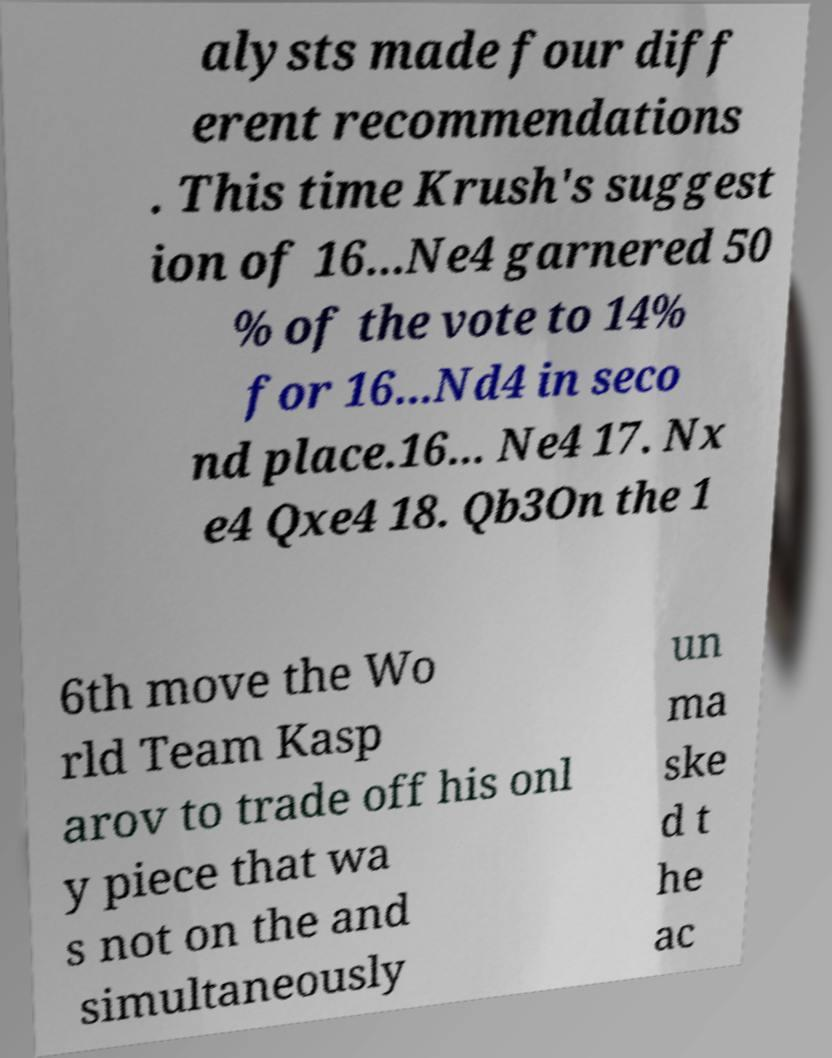Can you read and provide the text displayed in the image?This photo seems to have some interesting text. Can you extract and type it out for me? alysts made four diff erent recommendations . This time Krush's suggest ion of 16...Ne4 garnered 50 % of the vote to 14% for 16...Nd4 in seco nd place.16... Ne4 17. Nx e4 Qxe4 18. Qb3On the 1 6th move the Wo rld Team Kasp arov to trade off his onl y piece that wa s not on the and simultaneously un ma ske d t he ac 